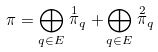<formula> <loc_0><loc_0><loc_500><loc_500>\pi = \bigoplus _ { q \in E } \stackrel { 1 } { \pi } _ { q } + \bigoplus _ { q \in E } \stackrel { 2 } { \pi } _ { q }</formula> 